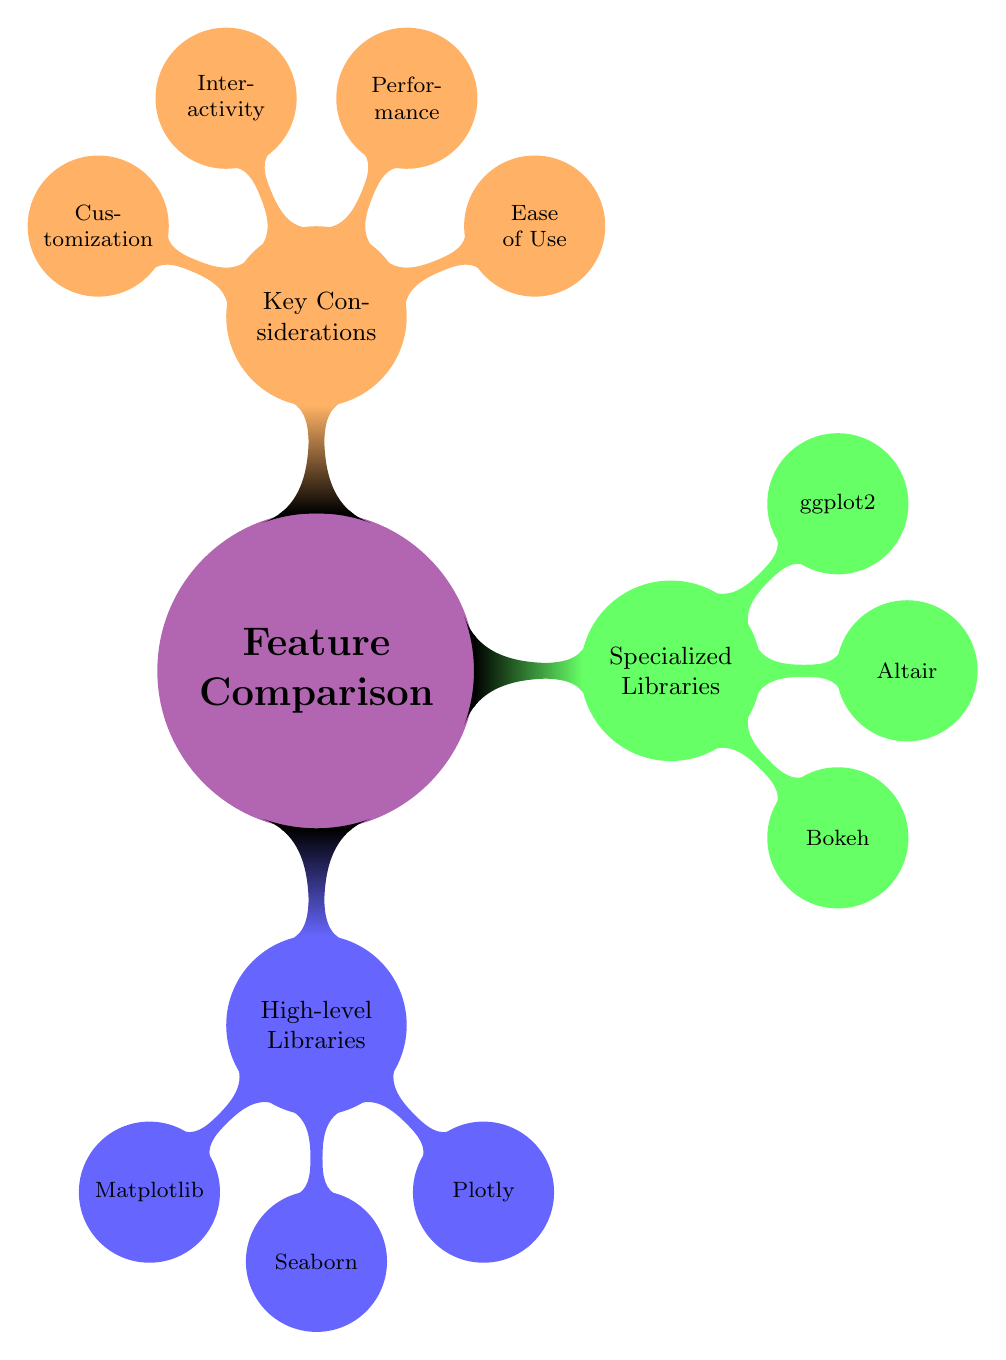What are the three high-level libraries listed? The node titled "High-level Libraries" has three children: "Matplotlib," "Seaborn," and "Plotly." These are the names of the libraries displayed directly under this section.
Answer: Matplotlib, Seaborn, Plotly Which library is known for its beautiful default styles? The node for "Seaborn" has a "Pros" section where it specifically mentions "Beautiful default styles." Hence, Seaborn is recognized for this quality.
Answer: Seaborn How many key considerations are mentioned in the diagram? The node titled "Key Considerations" lists four subnodes: "Ease of Use," "Performance," "Interactivity," and "Customization." Counting these gives a total of four considerations.
Answer: 4 Which pros are associated with Plotly? The node for "Plotly" lists three pros: "Highly interactive," "Good for web-based visualizations," and "Supports a variety of chart types." These items are mentioned as advantages of using Plotly.
Answer: Highly interactive, Good for web-based visualizations, Supports a variety of chart types What is a con of using Matplotlib? One of the cons listed under "Matplotlib" is "Steeper learning curve." This indicates a potential drawback of the library.
Answer: Steeper learning curve Which library is part of the R ecosystem? The node for "ggplot2" indicates one of its cons is being "Part of R ecosystem." This highlights its association with the R programming language specifically.
Answer: ggplot2 What type of libraries does Bokeh represent? The node for "Bokeh" is listed under "Specialized Libraries." This categorization tells us that Bokeh is considered a specialized library for visualization.
Answer: Specialized Libraries Which library has limited customization options? The node for "Altair" specifies under its cons that it has "Limited in customization," which directly answers this question about its capabilities.
Answer: Altair 